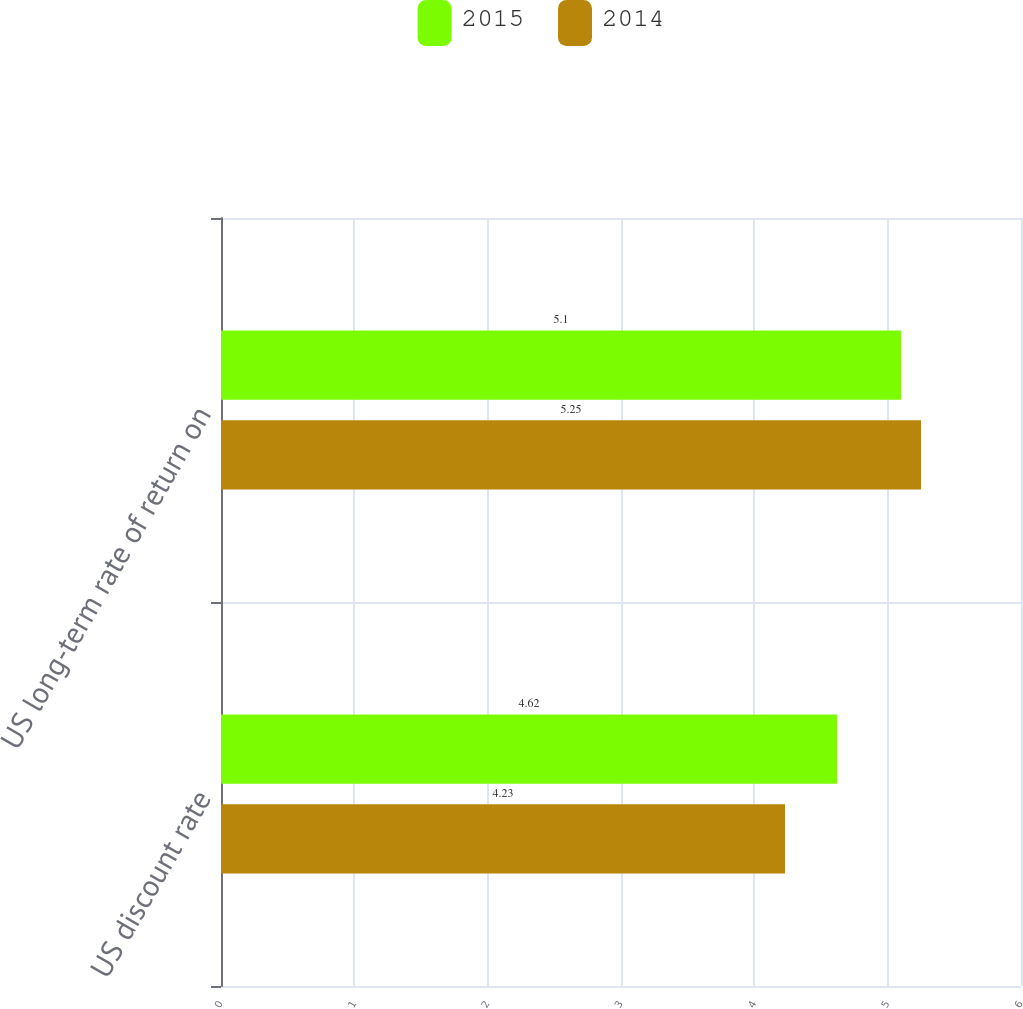Convert chart. <chart><loc_0><loc_0><loc_500><loc_500><stacked_bar_chart><ecel><fcel>US discount rate<fcel>US long-term rate of return on<nl><fcel>2015<fcel>4.62<fcel>5.1<nl><fcel>2014<fcel>4.23<fcel>5.25<nl></chart> 